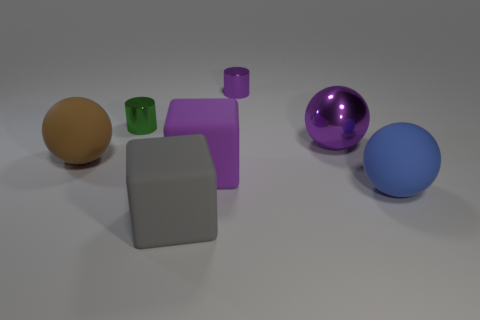There is a large purple object right of the large purple rubber object; does it have the same shape as the large blue thing?
Keep it short and to the point. Yes. There is a metal cylinder that is behind the metal cylinder that is on the left side of the gray cube; what color is it?
Make the answer very short. Purple. Are there fewer tiny metallic cubes than large purple shiny balls?
Your answer should be very brief. Yes. Are there any small purple cylinders that have the same material as the purple ball?
Give a very brief answer. Yes. Does the gray rubber object have the same shape as the big purple object that is left of the large purple sphere?
Your answer should be compact. Yes. There is a blue matte object; are there any large gray matte things behind it?
Provide a succinct answer. No. How many tiny green things are the same shape as the large brown matte thing?
Ensure brevity in your answer.  0. Does the blue thing have the same material as the large purple thing behind the purple matte object?
Your answer should be very brief. No. What number of large blue matte things are there?
Your response must be concise. 1. What size is the metal cylinder on the left side of the small purple cylinder?
Your answer should be compact. Small. 